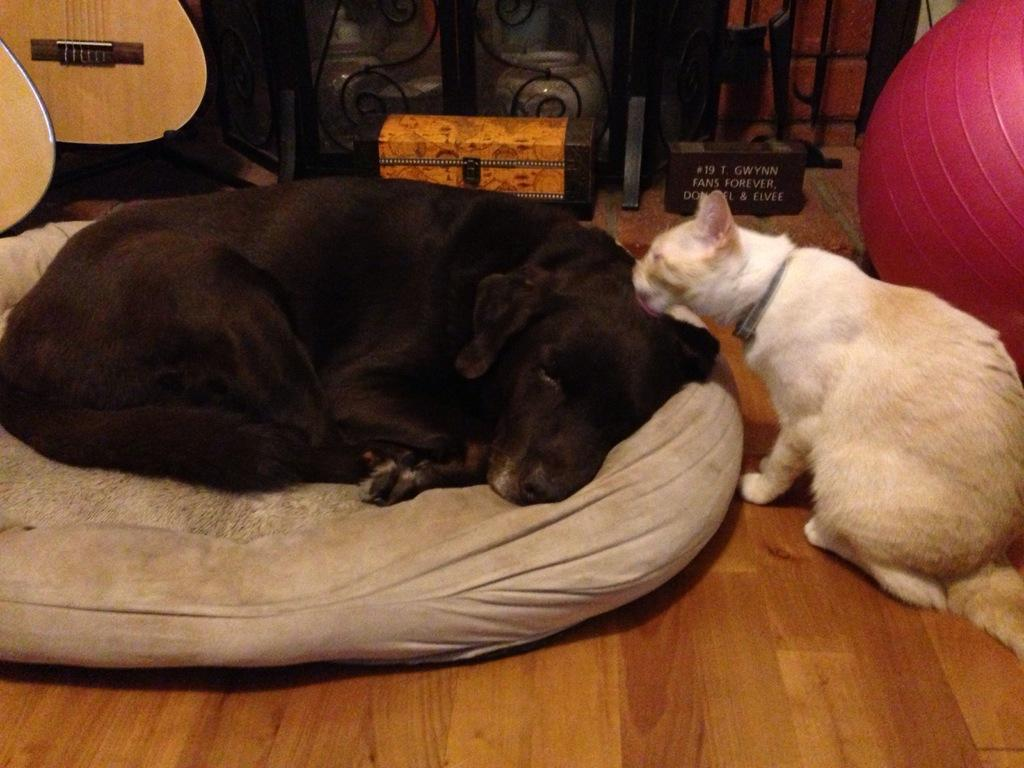What type of animal is on the pillow in the image? There is a dog on a pillow in the image. What other animal is present in the image? There is a cat on the floor in the image. What objects can be seen in the background of the image? There is a box, a guitar, and a ball in the background of the image. What letters are being discussed by the dog and cat in the image? There are no letters being discussed in the image, as it features a dog on a pillow and a cat on the floor, along with various objects in the background. 